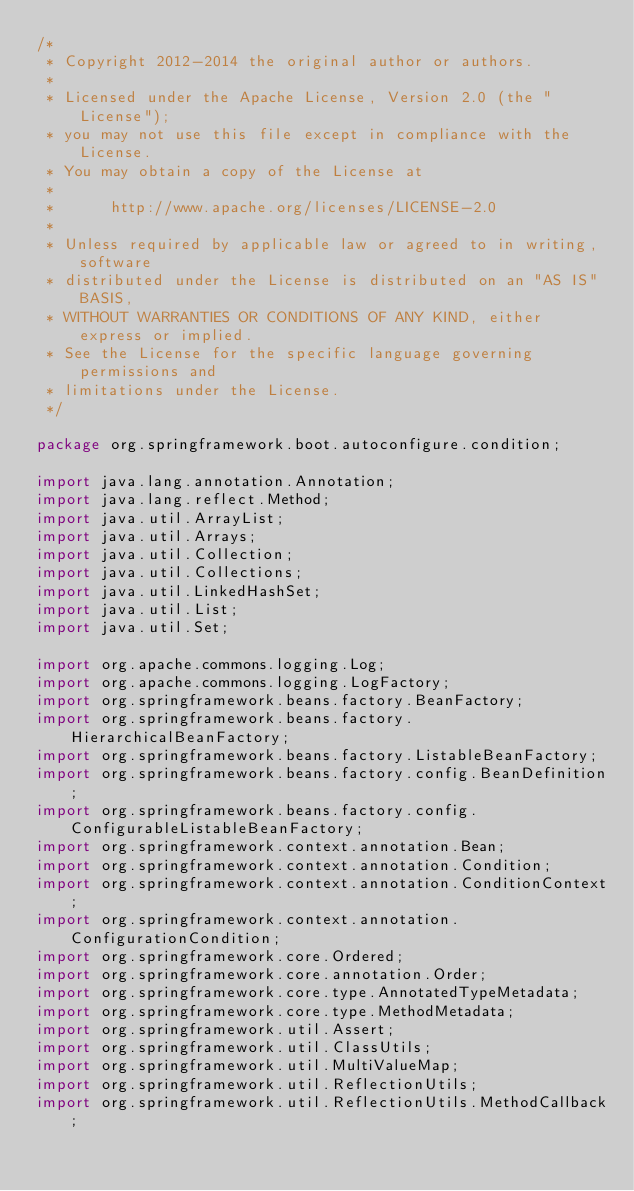<code> <loc_0><loc_0><loc_500><loc_500><_Java_>/*
 * Copyright 2012-2014 the original author or authors.
 *
 * Licensed under the Apache License, Version 2.0 (the "License");
 * you may not use this file except in compliance with the License.
 * You may obtain a copy of the License at
 *
 *      http://www.apache.org/licenses/LICENSE-2.0
 *
 * Unless required by applicable law or agreed to in writing, software
 * distributed under the License is distributed on an "AS IS" BASIS,
 * WITHOUT WARRANTIES OR CONDITIONS OF ANY KIND, either express or implied.
 * See the License for the specific language governing permissions and
 * limitations under the License.
 */

package org.springframework.boot.autoconfigure.condition;

import java.lang.annotation.Annotation;
import java.lang.reflect.Method;
import java.util.ArrayList;
import java.util.Arrays;
import java.util.Collection;
import java.util.Collections;
import java.util.LinkedHashSet;
import java.util.List;
import java.util.Set;

import org.apache.commons.logging.Log;
import org.apache.commons.logging.LogFactory;
import org.springframework.beans.factory.BeanFactory;
import org.springframework.beans.factory.HierarchicalBeanFactory;
import org.springframework.beans.factory.ListableBeanFactory;
import org.springframework.beans.factory.config.BeanDefinition;
import org.springframework.beans.factory.config.ConfigurableListableBeanFactory;
import org.springframework.context.annotation.Bean;
import org.springframework.context.annotation.Condition;
import org.springframework.context.annotation.ConditionContext;
import org.springframework.context.annotation.ConfigurationCondition;
import org.springframework.core.Ordered;
import org.springframework.core.annotation.Order;
import org.springframework.core.type.AnnotatedTypeMetadata;
import org.springframework.core.type.MethodMetadata;
import org.springframework.util.Assert;
import org.springframework.util.ClassUtils;
import org.springframework.util.MultiValueMap;
import org.springframework.util.ReflectionUtils;
import org.springframework.util.ReflectionUtils.MethodCallback;</code> 